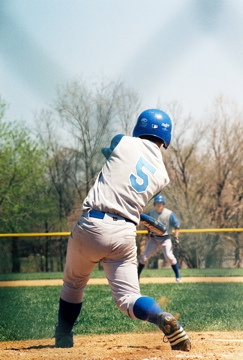Describe the objects in this image and their specific colors. I can see people in lightblue, white, gray, and black tones, people in lightblue, gray, darkgray, and lightgray tones, and baseball bat in lightblue, black, gray, and darkgray tones in this image. 